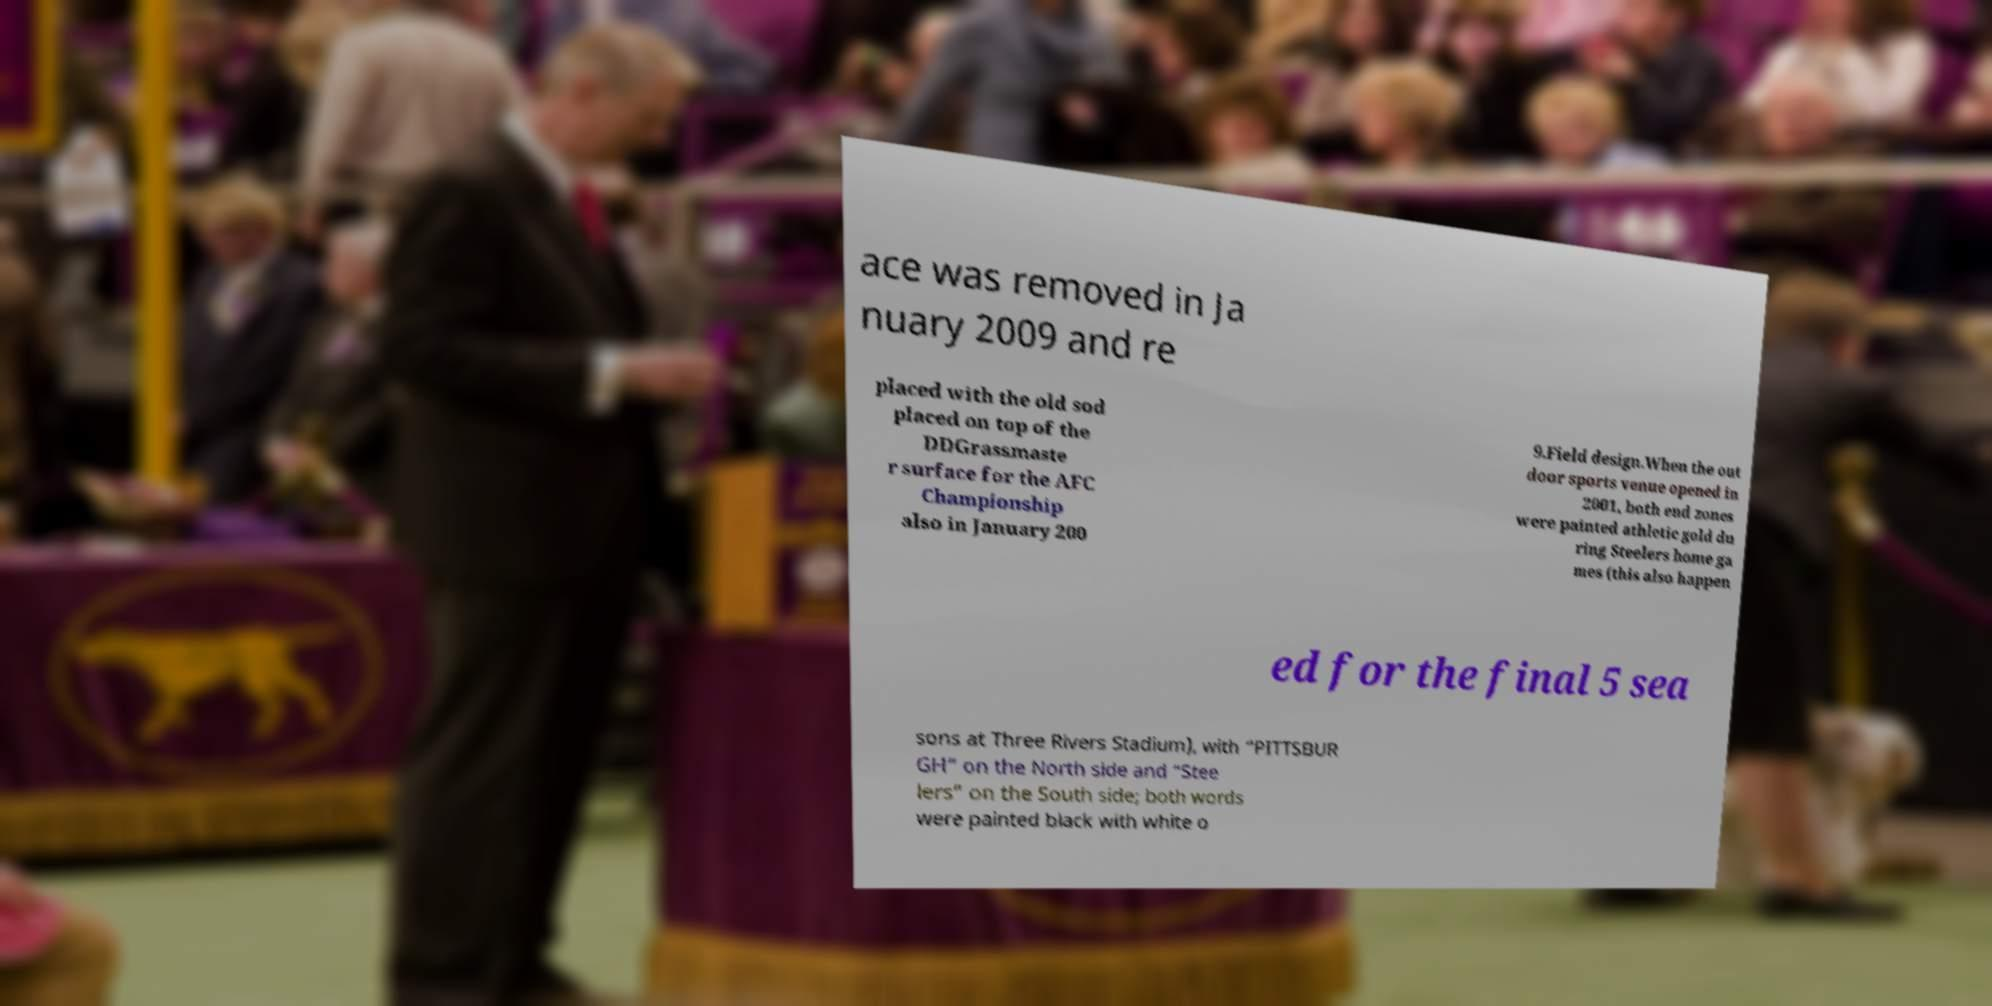For documentation purposes, I need the text within this image transcribed. Could you provide that? ace was removed in Ja nuary 2009 and re placed with the old sod placed on top of the DDGrassmaste r surface for the AFC Championship also in January 200 9.Field design.When the out door sports venue opened in 2001, both end zones were painted athletic gold du ring Steelers home ga mes (this also happen ed for the final 5 sea sons at Three Rivers Stadium), with “PITTSBUR GH” on the North side and “Stee lers” on the South side; both words were painted black with white o 